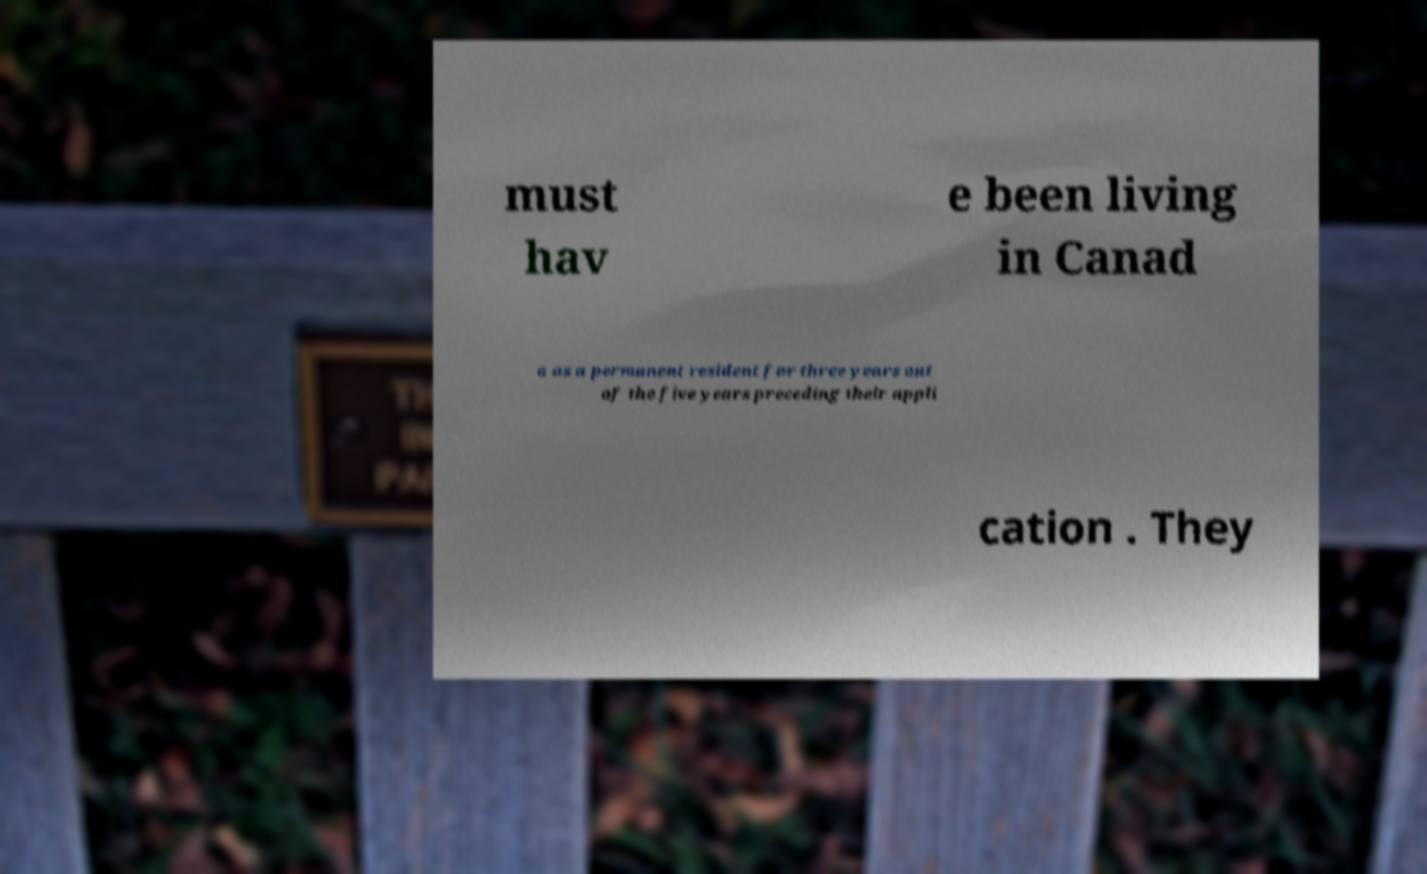Please read and relay the text visible in this image. What does it say? must hav e been living in Canad a as a permanent resident for three years out of the five years preceding their appli cation . They 